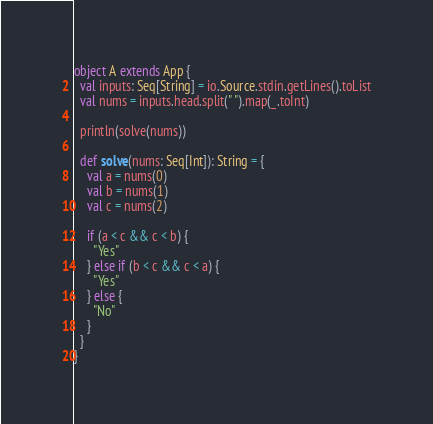<code> <loc_0><loc_0><loc_500><loc_500><_Scala_>object A extends App {
  val inputs: Seq[String] = io.Source.stdin.getLines().toList
  val nums = inputs.head.split(" ").map(_.toInt)

  println(solve(nums))

  def solve(nums: Seq[Int]): String = {
    val a = nums(0)
    val b = nums(1)
    val c = nums(2)

    if (a < c && c < b) {
      "Yes"
    } else if (b < c && c < a) {
      "Yes"
    } else {
      "No"
    }
  }
}
</code> 